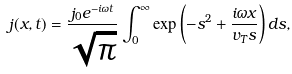Convert formula to latex. <formula><loc_0><loc_0><loc_500><loc_500>j ( x , t ) = \frac { j _ { 0 } e ^ { - i \omega t } } { \sqrt { \pi } } \int _ { 0 } ^ { \infty } \exp \left ( - s ^ { 2 } + \frac { i \omega x } { v _ { T } s } \right ) d s ,</formula> 